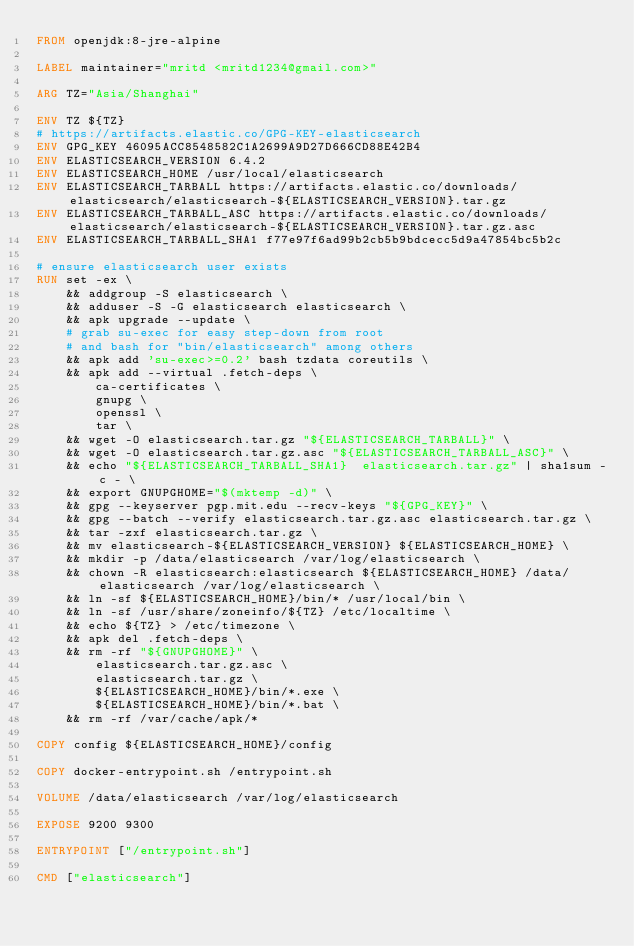Convert code to text. <code><loc_0><loc_0><loc_500><loc_500><_Dockerfile_>FROM openjdk:8-jre-alpine

LABEL maintainer="mritd <mritd1234@gmail.com>"

ARG TZ="Asia/Shanghai"

ENV TZ ${TZ}
# https://artifacts.elastic.co/GPG-KEY-elasticsearch
ENV GPG_KEY 46095ACC8548582C1A2699A9D27D666CD88E42B4
ENV ELASTICSEARCH_VERSION 6.4.2
ENV ELASTICSEARCH_HOME /usr/local/elasticsearch
ENV ELASTICSEARCH_TARBALL https://artifacts.elastic.co/downloads/elasticsearch/elasticsearch-${ELASTICSEARCH_VERSION}.tar.gz
ENV ELASTICSEARCH_TARBALL_ASC https://artifacts.elastic.co/downloads/elasticsearch/elasticsearch-${ELASTICSEARCH_VERSION}.tar.gz.asc
ENV ELASTICSEARCH_TARBALL_SHA1 f77e97f6ad99b2cb5b9bdcecc5d9a47854bc5b2c

# ensure elasticsearch user exists
RUN set -ex \
    && addgroup -S elasticsearch \
    && adduser -S -G elasticsearch elasticsearch \
    && apk upgrade --update \
    # grab su-exec for easy step-down from root
    # and bash for "bin/elasticsearch" among others
    && apk add 'su-exec>=0.2' bash tzdata coreutils \
    && apk add --virtual .fetch-deps \
        ca-certificates \
        gnupg \
        openssl \
        tar \
    && wget -O elasticsearch.tar.gz "${ELASTICSEARCH_TARBALL}" \
    && wget -O elasticsearch.tar.gz.asc "${ELASTICSEARCH_TARBALL_ASC}" \
    && echo "${ELASTICSEARCH_TARBALL_SHA1}  elasticsearch.tar.gz" | sha1sum -c - \
    && export GNUPGHOME="$(mktemp -d)" \
    && gpg --keyserver pgp.mit.edu --recv-keys "${GPG_KEY}" \
    && gpg --batch --verify elasticsearch.tar.gz.asc elasticsearch.tar.gz \
    && tar -zxf elasticsearch.tar.gz \
    && mv elasticsearch-${ELASTICSEARCH_VERSION} ${ELASTICSEARCH_HOME} \
    && mkdir -p /data/elasticsearch /var/log/elasticsearch \
    && chown -R elasticsearch:elasticsearch ${ELASTICSEARCH_HOME} /data/elasticsearch /var/log/elasticsearch \
    && ln -sf ${ELASTICSEARCH_HOME}/bin/* /usr/local/bin \
    && ln -sf /usr/share/zoneinfo/${TZ} /etc/localtime \
    && echo ${TZ} > /etc/timezone \
    && apk del .fetch-deps \
    && rm -rf "${GNUPGHOME}" \
        elasticsearch.tar.gz.asc \
        elasticsearch.tar.gz \
        ${ELASTICSEARCH_HOME}/bin/*.exe \
        ${ELASTICSEARCH_HOME}/bin/*.bat \
    && rm -rf /var/cache/apk/*

COPY config ${ELASTICSEARCH_HOME}/config

COPY docker-entrypoint.sh /entrypoint.sh

VOLUME /data/elasticsearch /var/log/elasticsearch 

EXPOSE 9200 9300

ENTRYPOINT ["/entrypoint.sh"]

CMD ["elasticsearch"]
</code> 